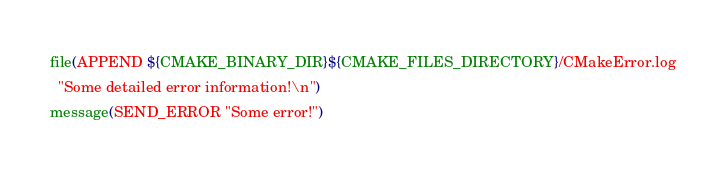<code> <loc_0><loc_0><loc_500><loc_500><_CMake_>file(APPEND ${CMAKE_BINARY_DIR}${CMAKE_FILES_DIRECTORY}/CMakeError.log
  "Some detailed error information!\n")
message(SEND_ERROR "Some error!")
</code> 